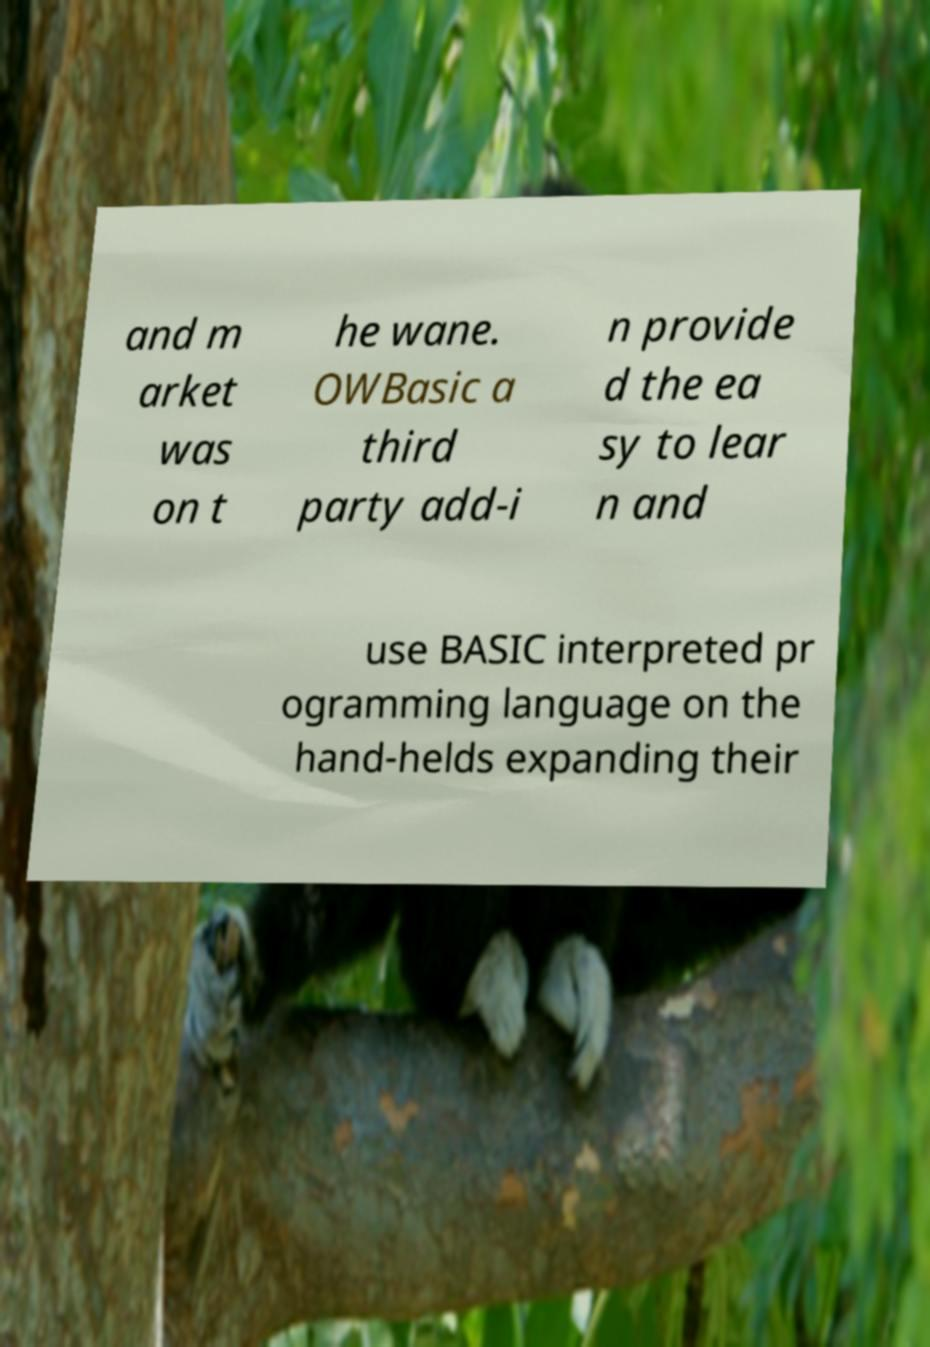Please read and relay the text visible in this image. What does it say? and m arket was on t he wane. OWBasic a third party add-i n provide d the ea sy to lear n and use BASIC interpreted pr ogramming language on the hand-helds expanding their 